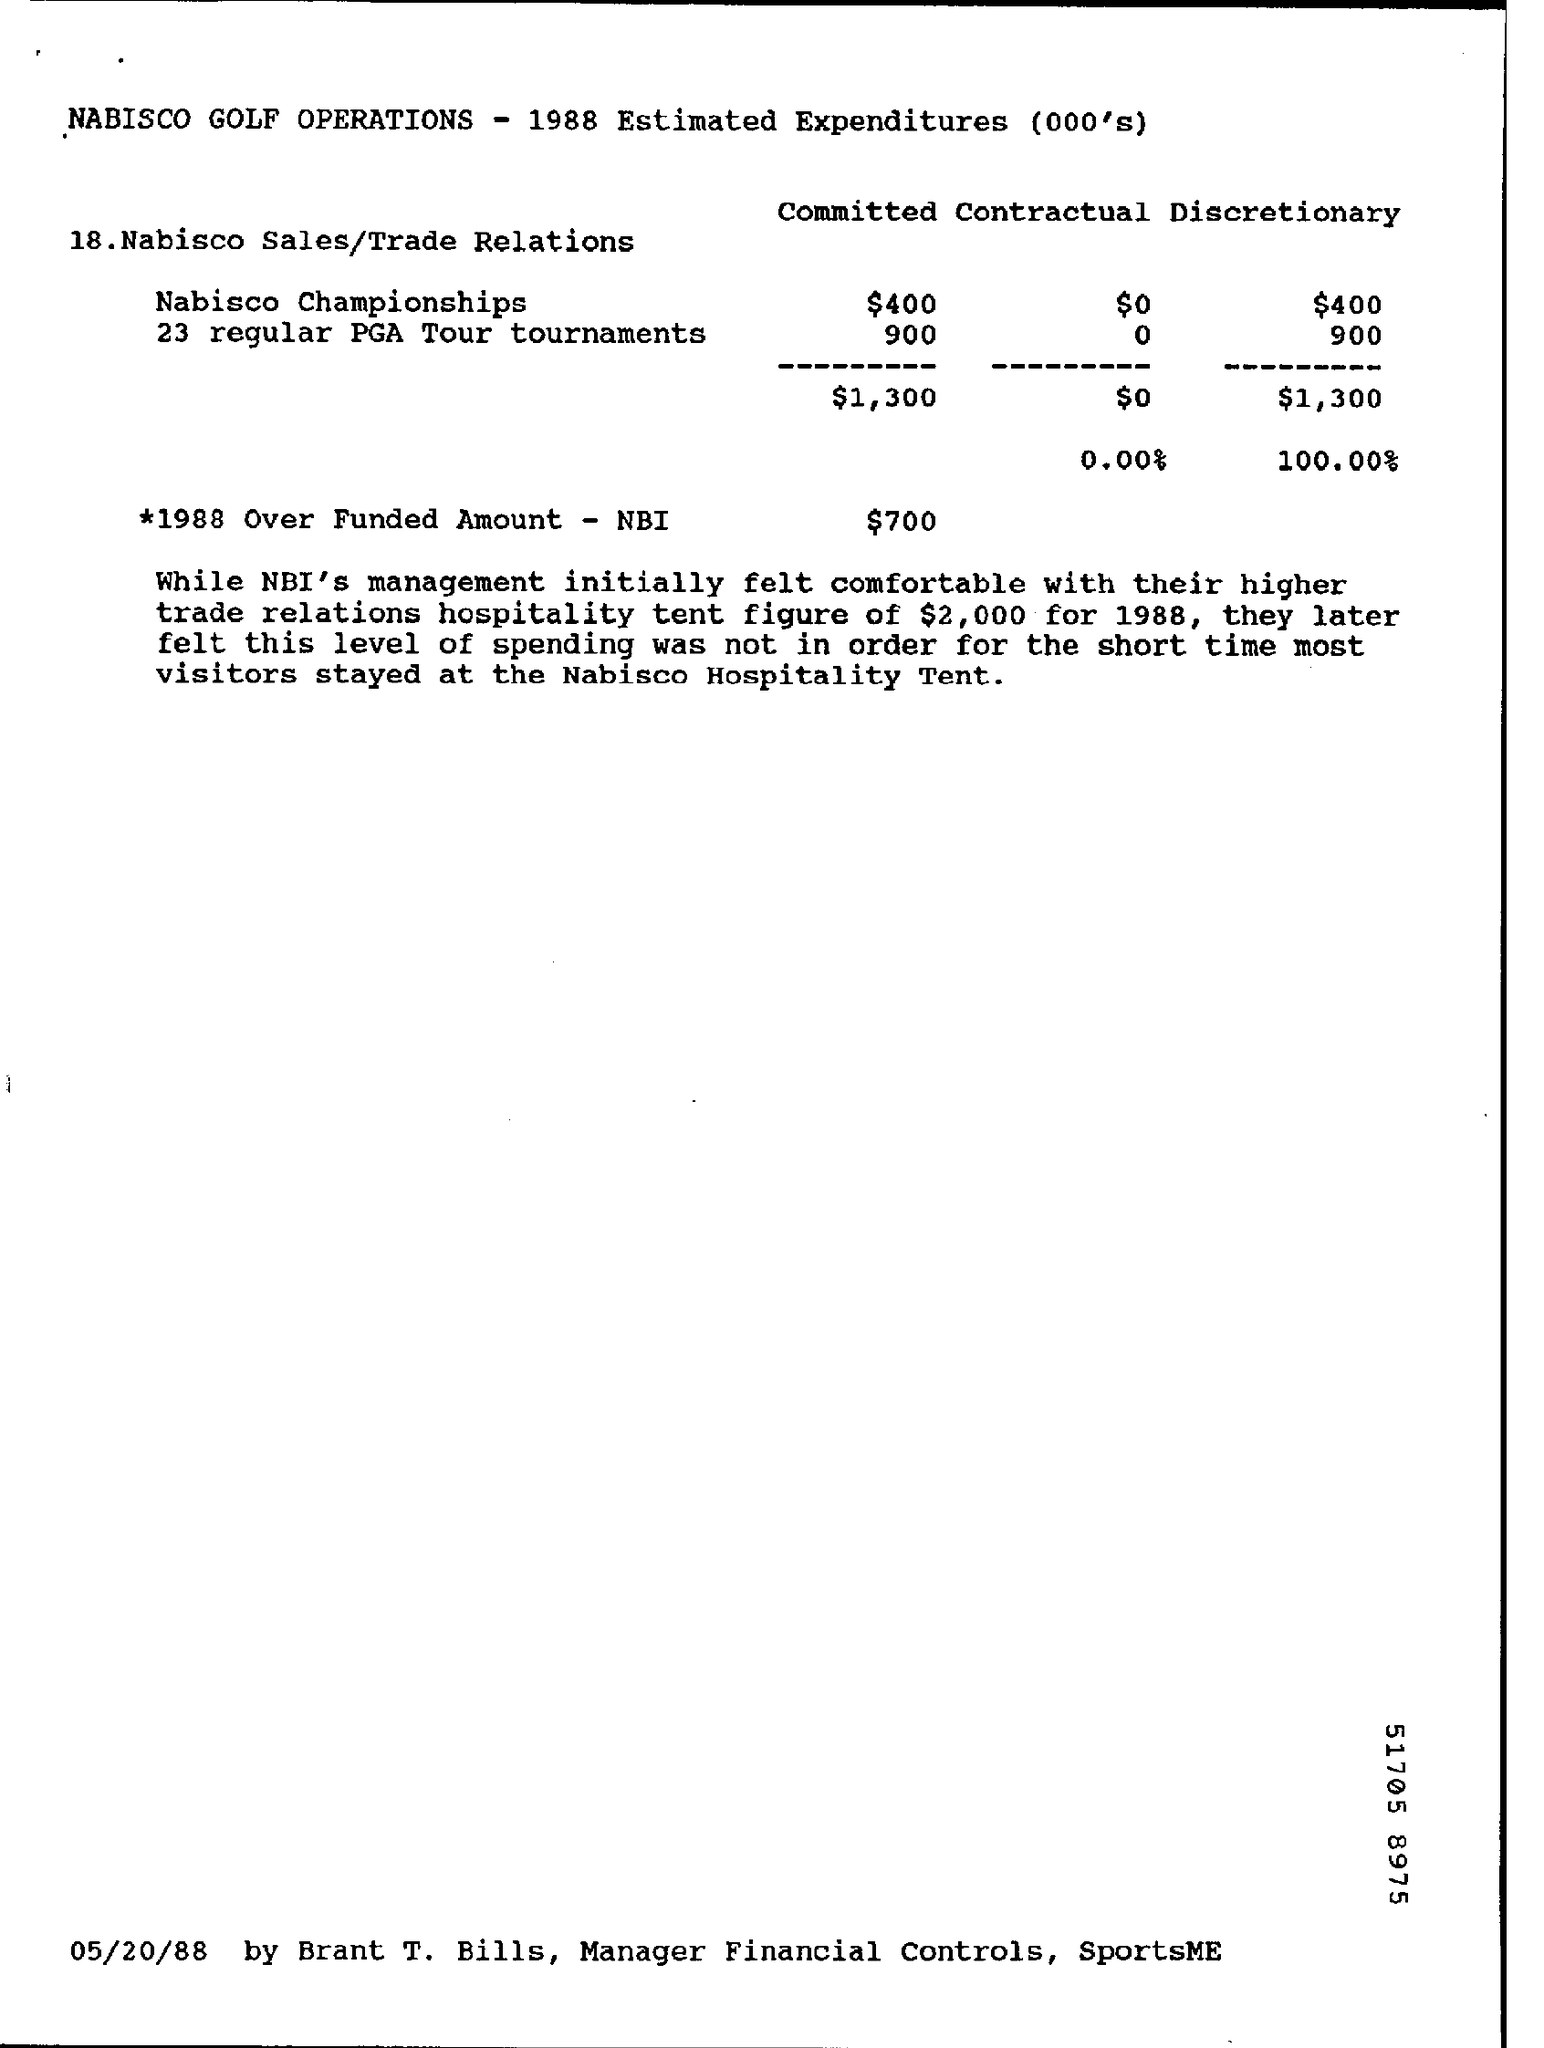What is the over funded amount -nbi in the year 1988 ?
Offer a terse response. $ 700. What is the estimated expenditure of total committed in nabisco sales/trade relations ?
Your answer should be compact. $1,300. What is the estimated expenditure of discretionary nabisco championships ?
Ensure brevity in your answer.  $400. What is the estimated expenditure of total discretionary in nabisco sales/trade relations ?/
Your answer should be compact. $1,300. 